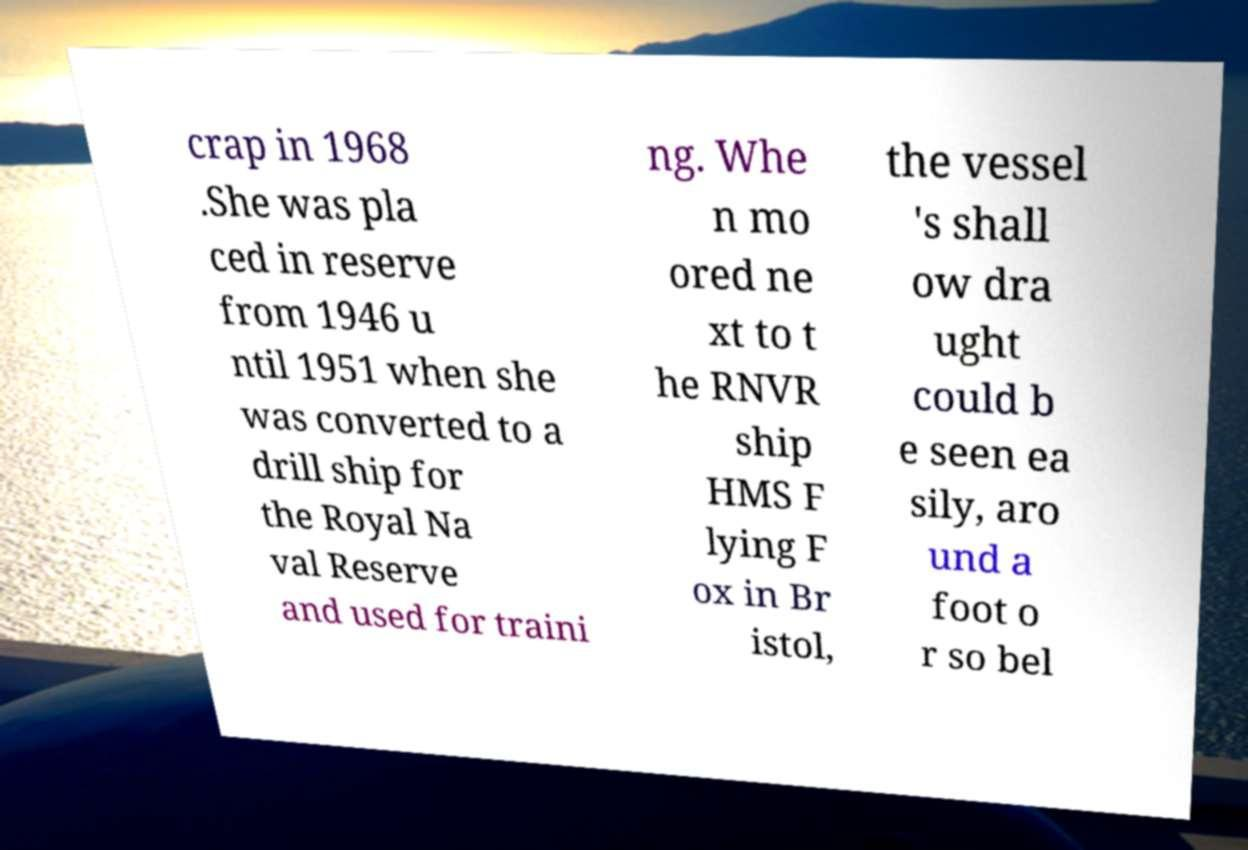Could you assist in decoding the text presented in this image and type it out clearly? crap in 1968 .She was pla ced in reserve from 1946 u ntil 1951 when she was converted to a drill ship for the Royal Na val Reserve and used for traini ng. Whe n mo ored ne xt to t he RNVR ship HMS F lying F ox in Br istol, the vessel 's shall ow dra ught could b e seen ea sily, aro und a foot o r so bel 